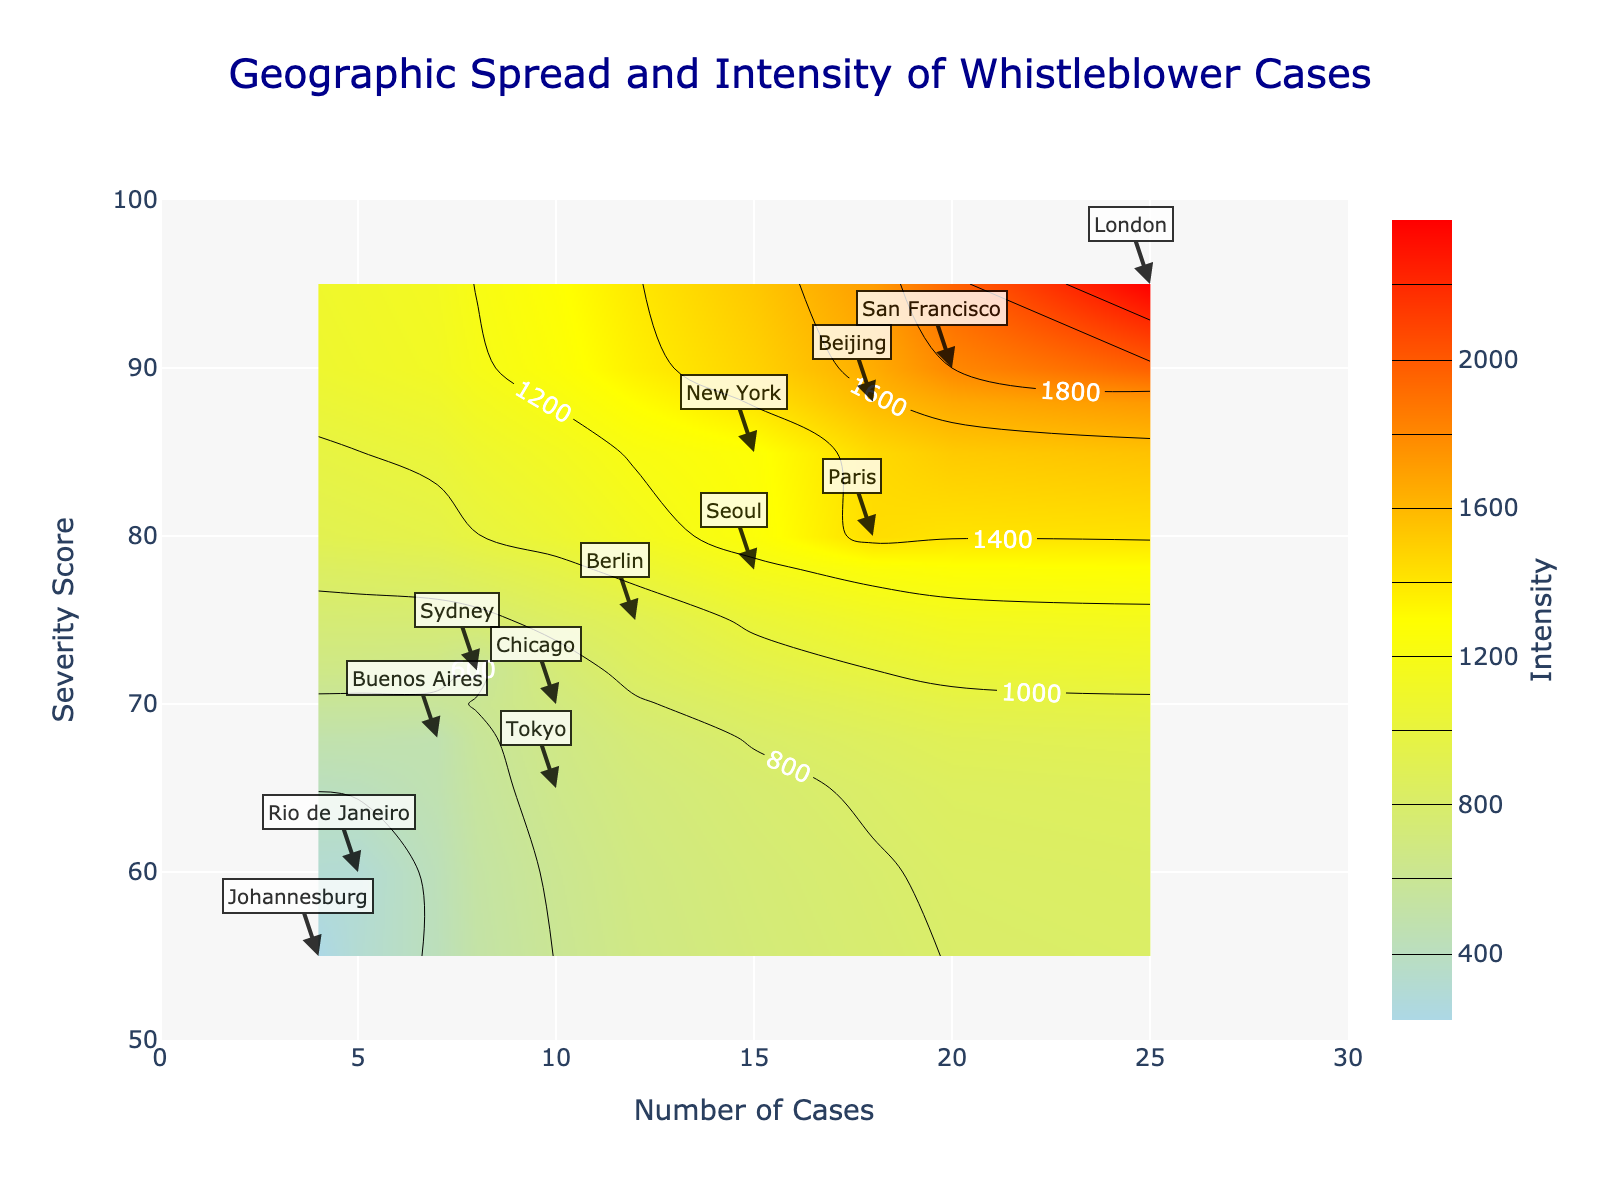What is the title of the figure? The title is displayed prominently at the top of the figure, usually in a larger and bold font for emphasis. It reads "Geographic Spread and Intensity of Whistleblower Cases".
Answer: Geographic Spread and Intensity of Whistleblower Cases How many cases does London have? By observing the annotation next to the data point labeled "London," we can see its value on the x-axis, which represents the number of cases.
Answer: 25 Which city has the highest severity score? The y-axis represents the severity score, and by looking for the highest data point along this axis, we find it corresponds to "London".
Answer: London What's the range of the severity score in the plot? The y-axis begins at 50 and ends at 100, as indicated by the axis labels. This range encapsulates all possible values.
Answer: 50 to 100 How is the intensity calculated in the plot? The intensity is calculated as the product of the number of cases and the severity score, as specified in the hovertemplate annotation.
Answer: Number of Cases * Severity Score Which region has the most cities represented in the plot? By counting the annotations, we find "North America" with New York, San Francisco, and Chicago (total 3), has the most cities compared to other regions.
Answer: North America Compare the intensity of Tokyo and Paris. Which is higher? The intensity is the product of the number of cases and the severity score. Calculations:
Tokyo: 10 * 65 = 650
Paris: 18 * 80 = 1440
Paris has a higher intensity.
Answer: Paris What is the intensity value for New York? Hovering over or looking at the annotation near New York, the product of the number of cases and severity score (15 * 85) is given as 1275.
Answer: 1275 How many cities have a severity score above 80? Observing the y-axis and corresponding data points, cities with severity scores above 80 include New York, San Francisco, London, Paris, and Beijing. Total cities: 5
Answer: 5 